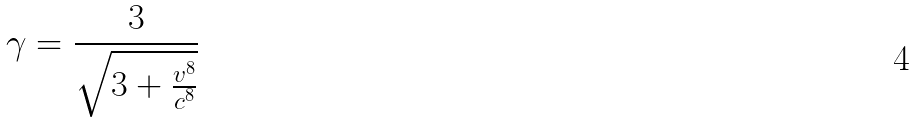Convert formula to latex. <formula><loc_0><loc_0><loc_500><loc_500>\gamma = \frac { 3 } { \sqrt { 3 + \frac { v ^ { 8 } } { c ^ { 8 } } } }</formula> 